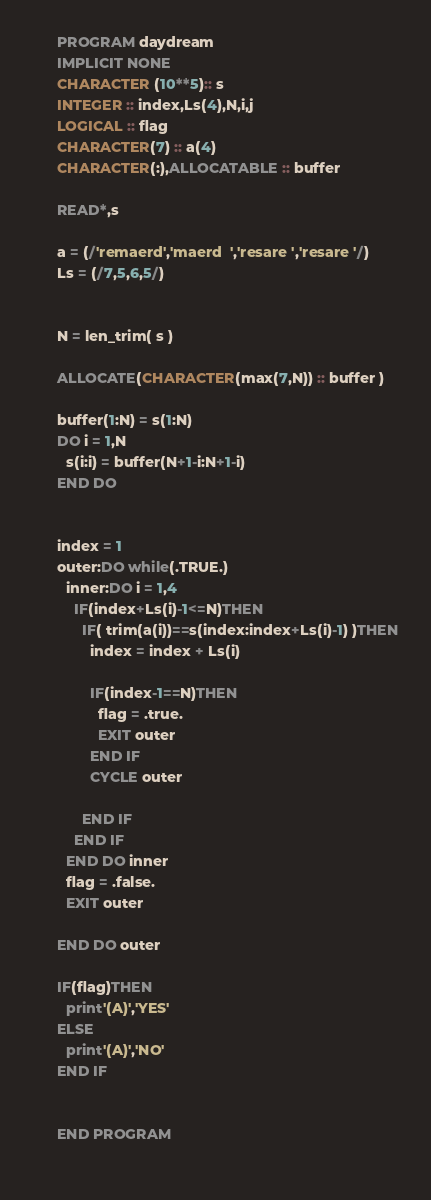<code> <loc_0><loc_0><loc_500><loc_500><_FORTRAN_>      PROGRAM daydream
      IMPLICIT NONE
      CHARACTER (10**5):: s
      INTEGER :: index,Ls(4),N,i,j
      LOGICAL :: flag
      CHARACTER(7) :: a(4)
      CHARACTER(:),ALLOCATABLE :: buffer
      
      READ*,s
      
      a = (/'remaerd','maerd  ','resare ','resare '/)
      Ls = (/7,5,6,5/)
      
      
      N = len_trim( s )
      
      ALLOCATE(CHARACTER(max(7,N)) :: buffer )
      
      buffer(1:N) = s(1:N)
      DO i = 1,N
        s(i:i) = buffer(N+1-i:N+1-i)
      END DO
      
      
      index = 1
      outer:DO while(.TRUE.)
        inner:DO i = 1,4
          IF(index+Ls(i)-1<=N)THEN
            IF( trim(a(i))==s(index:index+Ls(i)-1) )THEN
              index = index + Ls(i)
              
              IF(index-1==N)THEN
                flag = .true.
                EXIT outer
              END IF
              CYCLE outer
              
            END IF
          END IF
        END DO inner
        flag = .false.
        EXIT outer
        
      END DO outer
      
      IF(flag)THEN
        print'(A)','YES'
      ELSE
        print'(A)','NO'
      END IF
      
      
      END PROGRAM
      </code> 